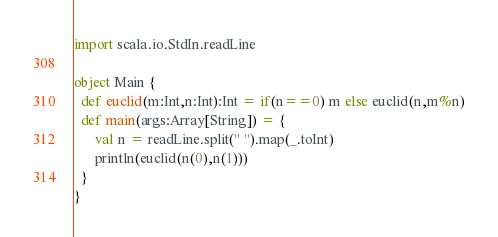<code> <loc_0><loc_0><loc_500><loc_500><_Scala_>import scala.io.StdIn.readLine
 
object Main {
  def euclid(m:Int,n:Int):Int = if(n==0) m else euclid(n,m%n)
  def main(args:Array[String]) = {
      val n = readLine.split(" ").map(_.toInt)
      println(euclid(n(0),n(1)))
  }
}</code> 